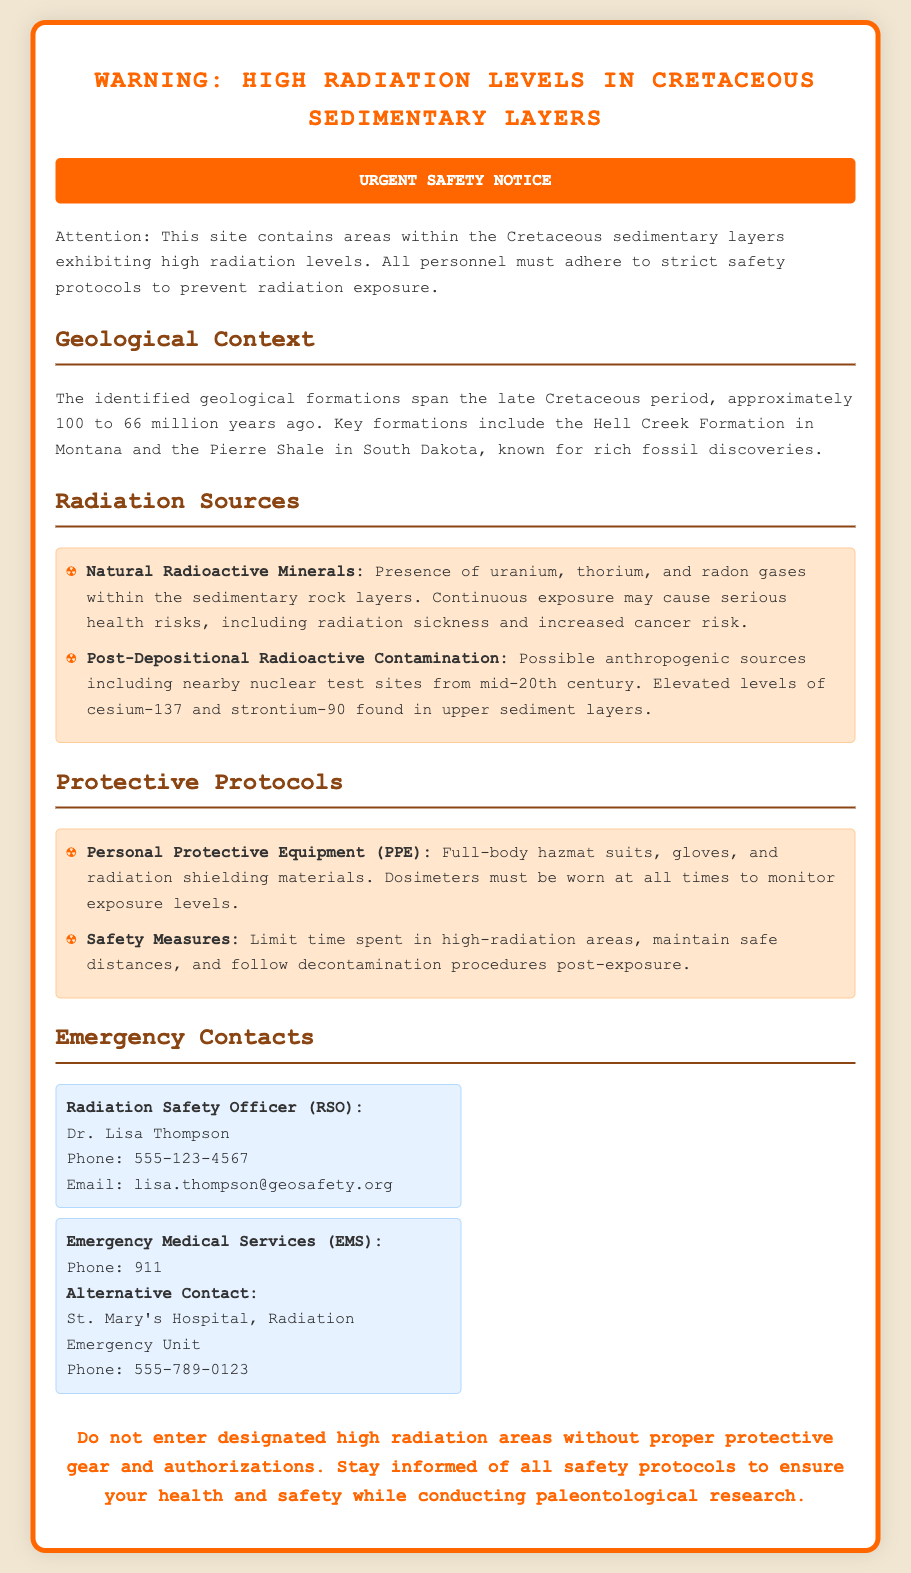What is the geological period discussed? The document specifies that the geological formations span the late Cretaceous period.
Answer: late Cretaceous Who is the Radiation Safety Officer? The document lists Dr. Lisa Thompson as the Radiation Safety Officer (RSO).
Answer: Dr. Lisa Thompson What are the two main sources of radiation mentioned? Natural radioactive minerals and post-depositional radioactive contamination are listed as main sources.
Answer: Natural radioactive minerals, post-depositional radioactive contamination What type of protective equipment is required? The document states that full-body hazmat suits are required as part of the protective gear.
Answer: full-body hazmat suits What must be worn to monitor exposure levels? The document specifies that dosimeters must be worn at all times to monitor exposure levels.
Answer: dosimeters How many emergency contacts are provided? The document lists a total of two emergency contacts: the Radiation Safety Officer and Emergency Medical Services.
Answer: two What is the warning about entering high radiation areas? The conclusion of the document emphasizes not to enter designated high radiation areas without proper protective gear.
Answer: Do not enter designated high radiation areas What types of health risks are associated with continuous exposure? The document mentions radiation sickness and increased cancer risk as health risks.
Answer: radiation sickness and increased cancer risk 